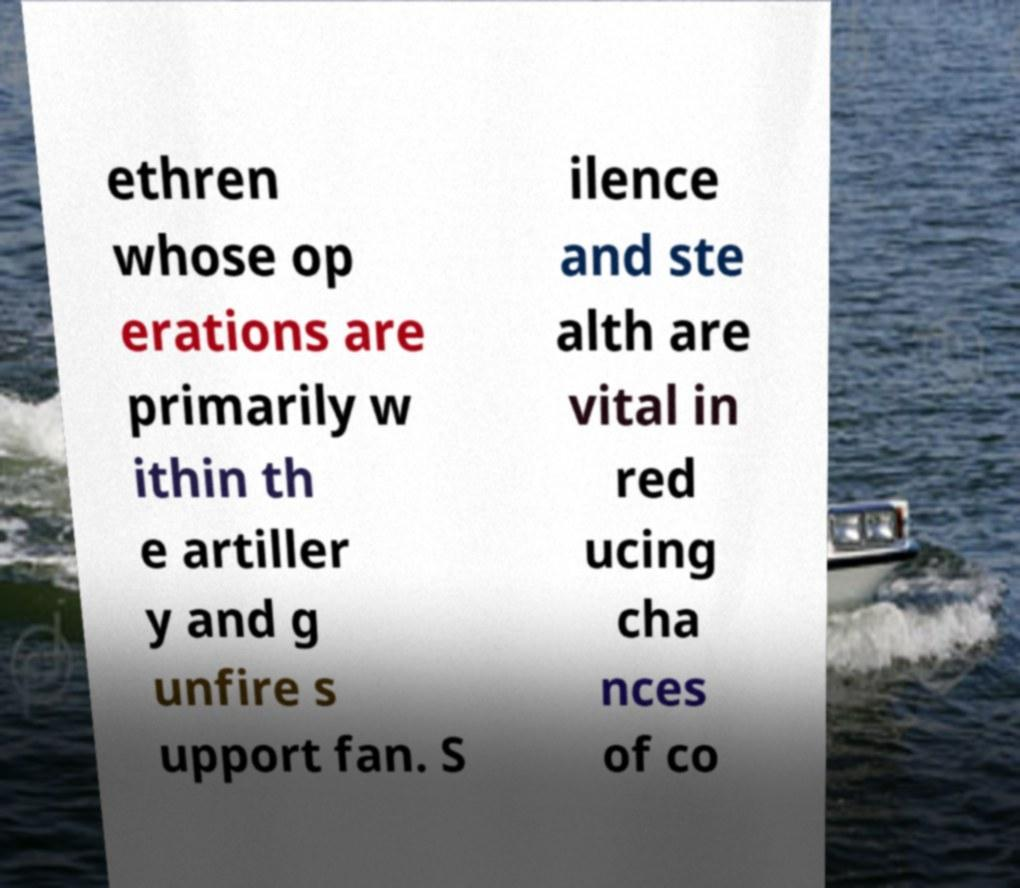I need the written content from this picture converted into text. Can you do that? ethren whose op erations are primarily w ithin th e artiller y and g unfire s upport fan. S ilence and ste alth are vital in red ucing cha nces of co 